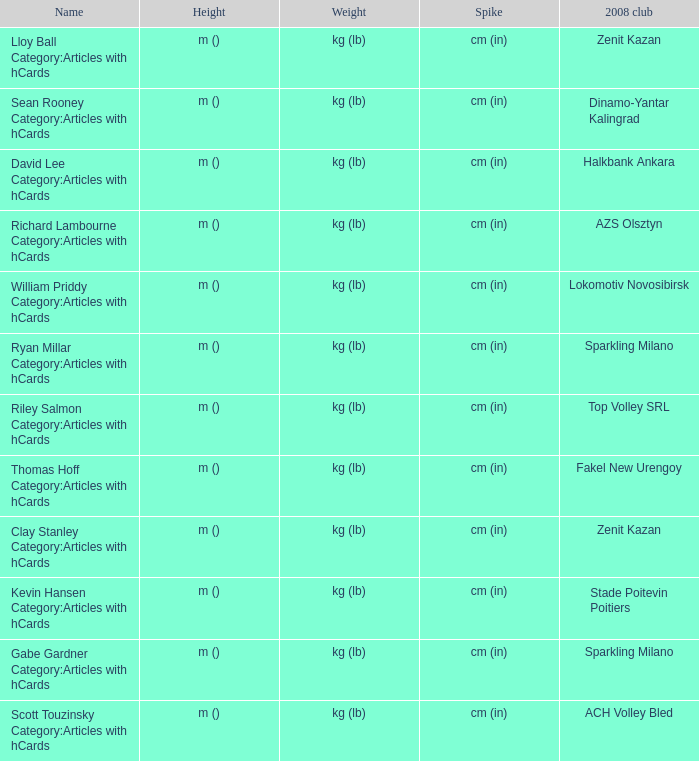What indicates the elevation for the 2008 club of stade poitevin poitiers? M (). 